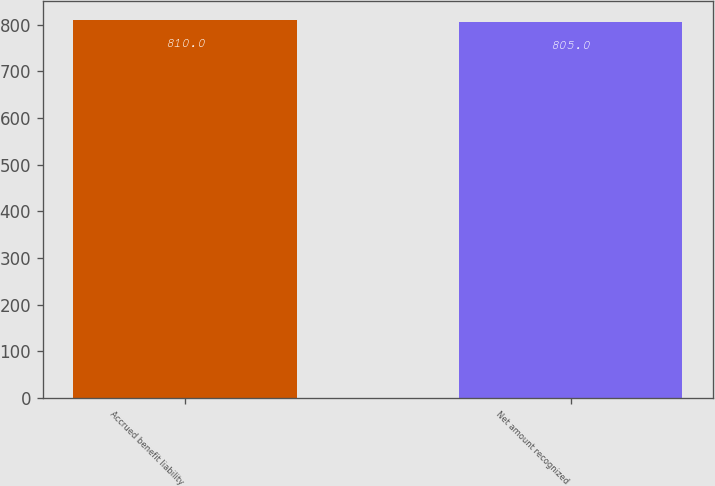Convert chart. <chart><loc_0><loc_0><loc_500><loc_500><bar_chart><fcel>Accrued benefit liability<fcel>Net amount recognized<nl><fcel>810<fcel>805<nl></chart> 